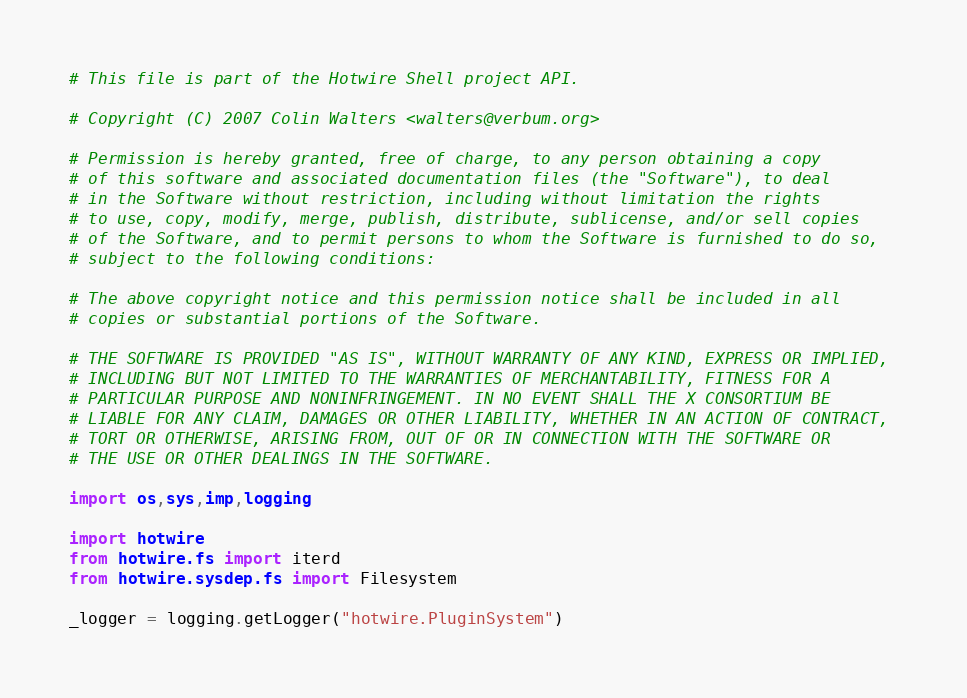<code> <loc_0><loc_0><loc_500><loc_500><_Python_># This file is part of the Hotwire Shell project API.

# Copyright (C) 2007 Colin Walters <walters@verbum.org>

# Permission is hereby granted, free of charge, to any person obtaining a copy 
# of this software and associated documentation files (the "Software"), to deal 
# in the Software without restriction, including without limitation the rights 
# to use, copy, modify, merge, publish, distribute, sublicense, and/or sell copies 
# of the Software, and to permit persons to whom the Software is furnished to do so, 
# subject to the following conditions:

# The above copyright notice and this permission notice shall be included in all 
# copies or substantial portions of the Software.

# THE SOFTWARE IS PROVIDED "AS IS", WITHOUT WARRANTY OF ANY KIND, EXPRESS OR IMPLIED,
# INCLUDING BUT NOT LIMITED TO THE WARRANTIES OF MERCHANTABILITY, FITNESS FOR A 
# PARTICULAR PURPOSE AND NONINFRINGEMENT. IN NO EVENT SHALL THE X CONSORTIUM BE 
# LIABLE FOR ANY CLAIM, DAMAGES OR OTHER LIABILITY, WHETHER IN AN ACTION OF CONTRACT, 
# TORT OR OTHERWISE, ARISING FROM, OUT OF OR IN CONNECTION WITH THE SOFTWARE OR 
# THE USE OR OTHER DEALINGS IN THE SOFTWARE.

import os,sys,imp,logging

import hotwire
from hotwire.fs import iterd
from hotwire.sysdep.fs import Filesystem

_logger = logging.getLogger("hotwire.PluginSystem")
</code> 